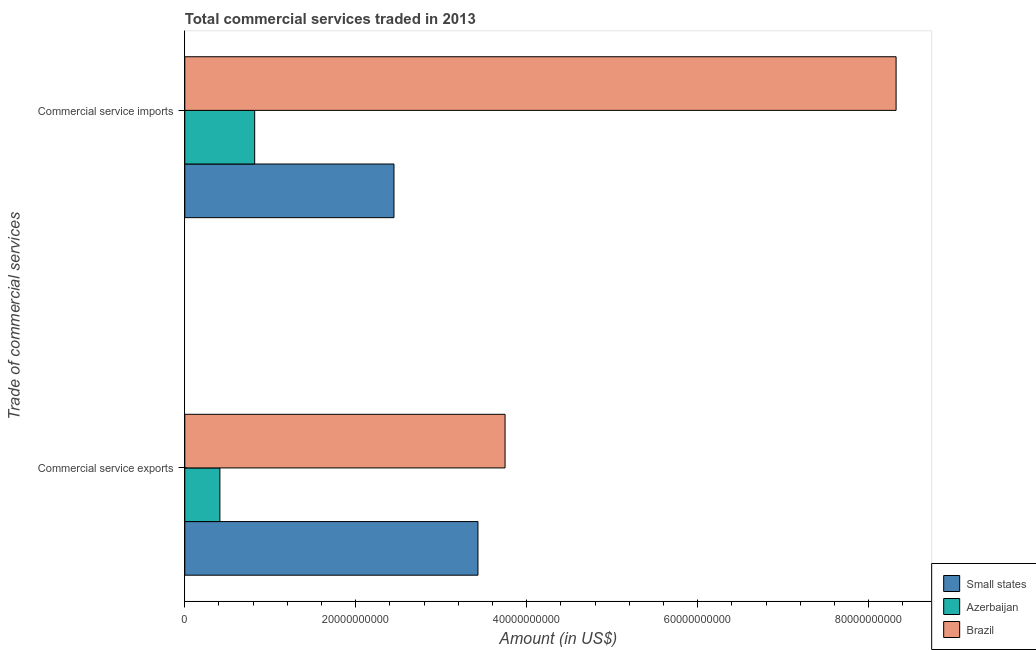How many groups of bars are there?
Keep it short and to the point. 2. Are the number of bars per tick equal to the number of legend labels?
Offer a terse response. Yes. Are the number of bars on each tick of the Y-axis equal?
Give a very brief answer. Yes. What is the label of the 2nd group of bars from the top?
Ensure brevity in your answer.  Commercial service exports. What is the amount of commercial service exports in Azerbaijan?
Make the answer very short. 4.11e+09. Across all countries, what is the maximum amount of commercial service imports?
Make the answer very short. 8.32e+1. Across all countries, what is the minimum amount of commercial service imports?
Your answer should be compact. 8.18e+09. In which country was the amount of commercial service imports minimum?
Provide a succinct answer. Azerbaijan. What is the total amount of commercial service exports in the graph?
Offer a very short reply. 7.59e+1. What is the difference between the amount of commercial service imports in Azerbaijan and that in Brazil?
Give a very brief answer. -7.50e+1. What is the difference between the amount of commercial service exports in Small states and the amount of commercial service imports in Azerbaijan?
Your answer should be very brief. 2.61e+1. What is the average amount of commercial service exports per country?
Offer a terse response. 2.53e+1. What is the difference between the amount of commercial service exports and amount of commercial service imports in Brazil?
Offer a terse response. -4.57e+1. In how many countries, is the amount of commercial service imports greater than 72000000000 US$?
Your answer should be very brief. 1. What is the ratio of the amount of commercial service imports in Small states to that in Azerbaijan?
Provide a short and direct response. 2.99. What does the 3rd bar from the top in Commercial service exports represents?
Make the answer very short. Small states. What does the 2nd bar from the bottom in Commercial service imports represents?
Your answer should be compact. Azerbaijan. How many bars are there?
Provide a succinct answer. 6. Are the values on the major ticks of X-axis written in scientific E-notation?
Offer a terse response. No. Does the graph contain any zero values?
Give a very brief answer. No. How many legend labels are there?
Your answer should be compact. 3. How are the legend labels stacked?
Offer a terse response. Vertical. What is the title of the graph?
Your response must be concise. Total commercial services traded in 2013. What is the label or title of the Y-axis?
Keep it short and to the point. Trade of commercial services. What is the Amount (in US$) of Small states in Commercial service exports?
Your answer should be compact. 3.43e+1. What is the Amount (in US$) of Azerbaijan in Commercial service exports?
Your answer should be very brief. 4.11e+09. What is the Amount (in US$) in Brazil in Commercial service exports?
Your answer should be compact. 3.75e+1. What is the Amount (in US$) of Small states in Commercial service imports?
Provide a succinct answer. 2.45e+1. What is the Amount (in US$) in Azerbaijan in Commercial service imports?
Keep it short and to the point. 8.18e+09. What is the Amount (in US$) of Brazil in Commercial service imports?
Make the answer very short. 8.32e+1. Across all Trade of commercial services, what is the maximum Amount (in US$) of Small states?
Offer a very short reply. 3.43e+1. Across all Trade of commercial services, what is the maximum Amount (in US$) of Azerbaijan?
Ensure brevity in your answer.  8.18e+09. Across all Trade of commercial services, what is the maximum Amount (in US$) of Brazil?
Keep it short and to the point. 8.32e+1. Across all Trade of commercial services, what is the minimum Amount (in US$) in Small states?
Ensure brevity in your answer.  2.45e+1. Across all Trade of commercial services, what is the minimum Amount (in US$) in Azerbaijan?
Give a very brief answer. 4.11e+09. Across all Trade of commercial services, what is the minimum Amount (in US$) in Brazil?
Keep it short and to the point. 3.75e+1. What is the total Amount (in US$) in Small states in the graph?
Your answer should be very brief. 5.88e+1. What is the total Amount (in US$) in Azerbaijan in the graph?
Make the answer very short. 1.23e+1. What is the total Amount (in US$) of Brazil in the graph?
Provide a succinct answer. 1.21e+11. What is the difference between the Amount (in US$) of Small states in Commercial service exports and that in Commercial service imports?
Your answer should be compact. 9.82e+09. What is the difference between the Amount (in US$) in Azerbaijan in Commercial service exports and that in Commercial service imports?
Your answer should be compact. -4.07e+09. What is the difference between the Amount (in US$) of Brazil in Commercial service exports and that in Commercial service imports?
Your answer should be very brief. -4.57e+1. What is the difference between the Amount (in US$) in Small states in Commercial service exports and the Amount (in US$) in Azerbaijan in Commercial service imports?
Your response must be concise. 2.61e+1. What is the difference between the Amount (in US$) in Small states in Commercial service exports and the Amount (in US$) in Brazil in Commercial service imports?
Provide a short and direct response. -4.89e+1. What is the difference between the Amount (in US$) in Azerbaijan in Commercial service exports and the Amount (in US$) in Brazil in Commercial service imports?
Your answer should be very brief. -7.91e+1. What is the average Amount (in US$) in Small states per Trade of commercial services?
Give a very brief answer. 2.94e+1. What is the average Amount (in US$) in Azerbaijan per Trade of commercial services?
Ensure brevity in your answer.  6.14e+09. What is the average Amount (in US$) of Brazil per Trade of commercial services?
Provide a short and direct response. 6.03e+1. What is the difference between the Amount (in US$) of Small states and Amount (in US$) of Azerbaijan in Commercial service exports?
Ensure brevity in your answer.  3.02e+1. What is the difference between the Amount (in US$) of Small states and Amount (in US$) of Brazil in Commercial service exports?
Keep it short and to the point. -3.17e+09. What is the difference between the Amount (in US$) of Azerbaijan and Amount (in US$) of Brazil in Commercial service exports?
Make the answer very short. -3.34e+1. What is the difference between the Amount (in US$) in Small states and Amount (in US$) in Azerbaijan in Commercial service imports?
Your answer should be compact. 1.63e+1. What is the difference between the Amount (in US$) in Small states and Amount (in US$) in Brazil in Commercial service imports?
Your answer should be compact. -5.87e+1. What is the difference between the Amount (in US$) of Azerbaijan and Amount (in US$) of Brazil in Commercial service imports?
Offer a terse response. -7.50e+1. What is the ratio of the Amount (in US$) of Small states in Commercial service exports to that in Commercial service imports?
Offer a terse response. 1.4. What is the ratio of the Amount (in US$) in Azerbaijan in Commercial service exports to that in Commercial service imports?
Ensure brevity in your answer.  0.5. What is the ratio of the Amount (in US$) of Brazil in Commercial service exports to that in Commercial service imports?
Keep it short and to the point. 0.45. What is the difference between the highest and the second highest Amount (in US$) of Small states?
Your answer should be compact. 9.82e+09. What is the difference between the highest and the second highest Amount (in US$) in Azerbaijan?
Your response must be concise. 4.07e+09. What is the difference between the highest and the second highest Amount (in US$) in Brazil?
Your response must be concise. 4.57e+1. What is the difference between the highest and the lowest Amount (in US$) in Small states?
Offer a very short reply. 9.82e+09. What is the difference between the highest and the lowest Amount (in US$) of Azerbaijan?
Provide a succinct answer. 4.07e+09. What is the difference between the highest and the lowest Amount (in US$) in Brazil?
Provide a short and direct response. 4.57e+1. 